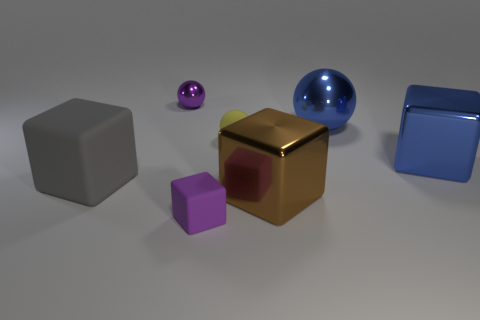Subtract all green blocks. Subtract all cyan cylinders. How many blocks are left? 4 Add 2 large brown cylinders. How many objects exist? 9 Subtract all balls. How many objects are left? 4 Subtract 1 yellow balls. How many objects are left? 6 Subtract all yellow balls. Subtract all large gray objects. How many objects are left? 5 Add 5 big brown shiny blocks. How many big brown shiny blocks are left? 6 Add 6 small cyan cubes. How many small cyan cubes exist? 6 